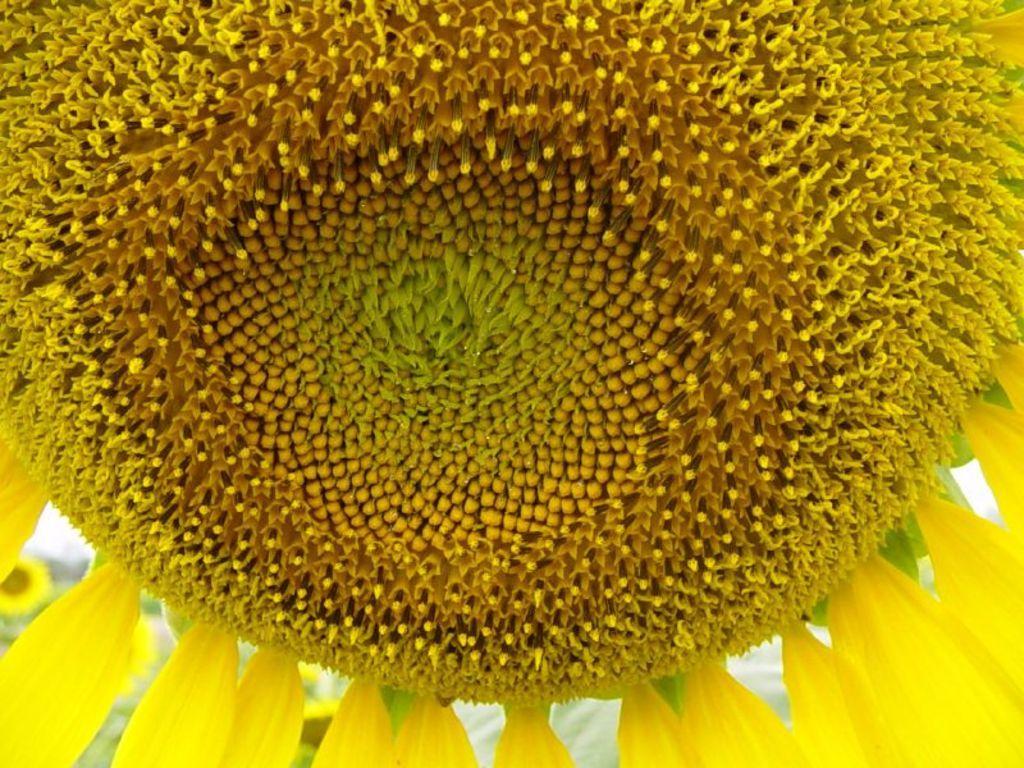Describe this image in one or two sentences. This is a close up image of a sunflower. 